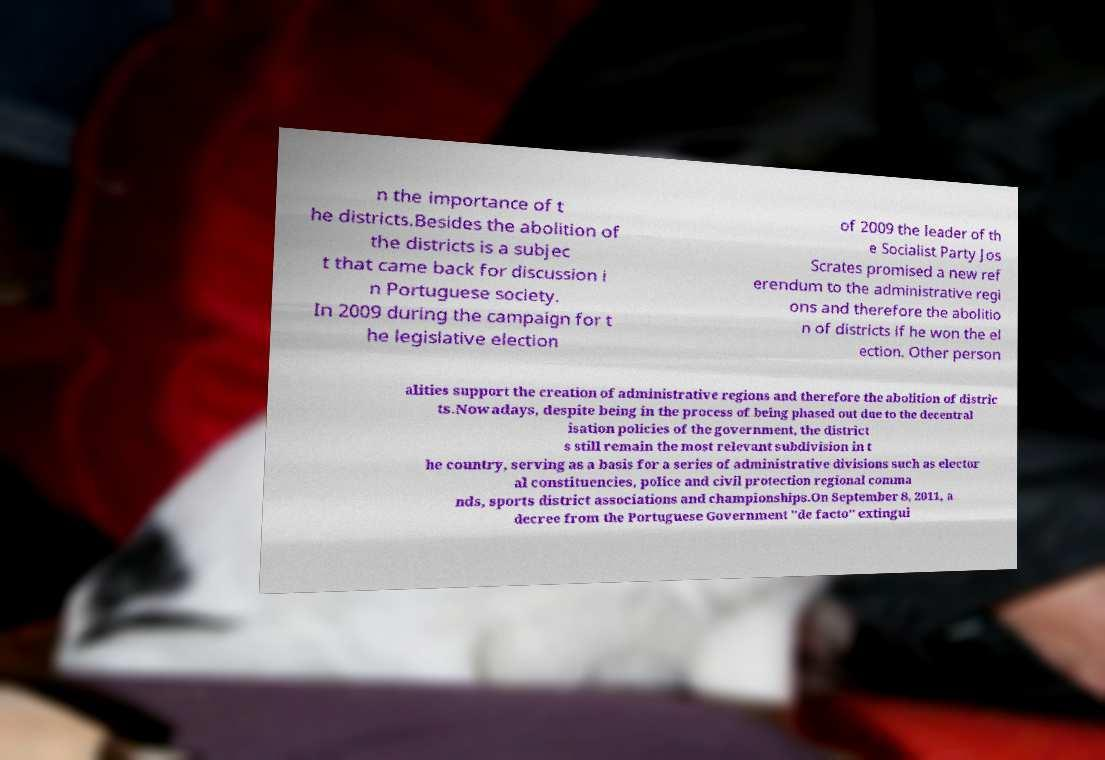Can you read and provide the text displayed in the image?This photo seems to have some interesting text. Can you extract and type it out for me? n the importance of t he districts.Besides the abolition of the districts is a subjec t that came back for discussion i n Portuguese society. In 2009 during the campaign for t he legislative election of 2009 the leader of th e Socialist Party Jos Scrates promised a new ref erendum to the administrative regi ons and therefore the abolitio n of districts if he won the el ection. Other person alities support the creation of administrative regions and therefore the abolition of distric ts.Nowadays, despite being in the process of being phased out due to the decentral isation policies of the government, the district s still remain the most relevant subdivision in t he country, serving as a basis for a series of administrative divisions such as elector al constituencies, police and civil protection regional comma nds, sports district associations and championships.On September 8, 2011, a decree from the Portuguese Government "de facto" extingui 